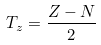Convert formula to latex. <formula><loc_0><loc_0><loc_500><loc_500>\ T _ { z } = \frac { Z - N } { 2 }</formula> 